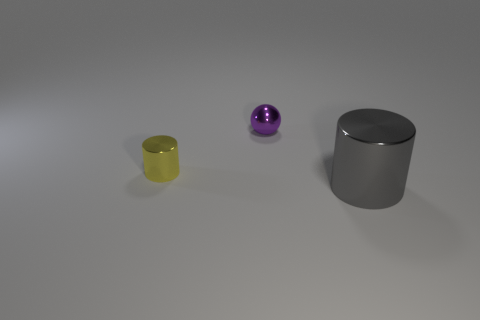Add 2 green things. How many objects exist? 5 Subtract all balls. How many objects are left? 2 Subtract all brown rubber objects. Subtract all small things. How many objects are left? 1 Add 3 gray metallic cylinders. How many gray metallic cylinders are left? 4 Add 2 gray shiny cubes. How many gray shiny cubes exist? 2 Subtract 0 yellow blocks. How many objects are left? 3 